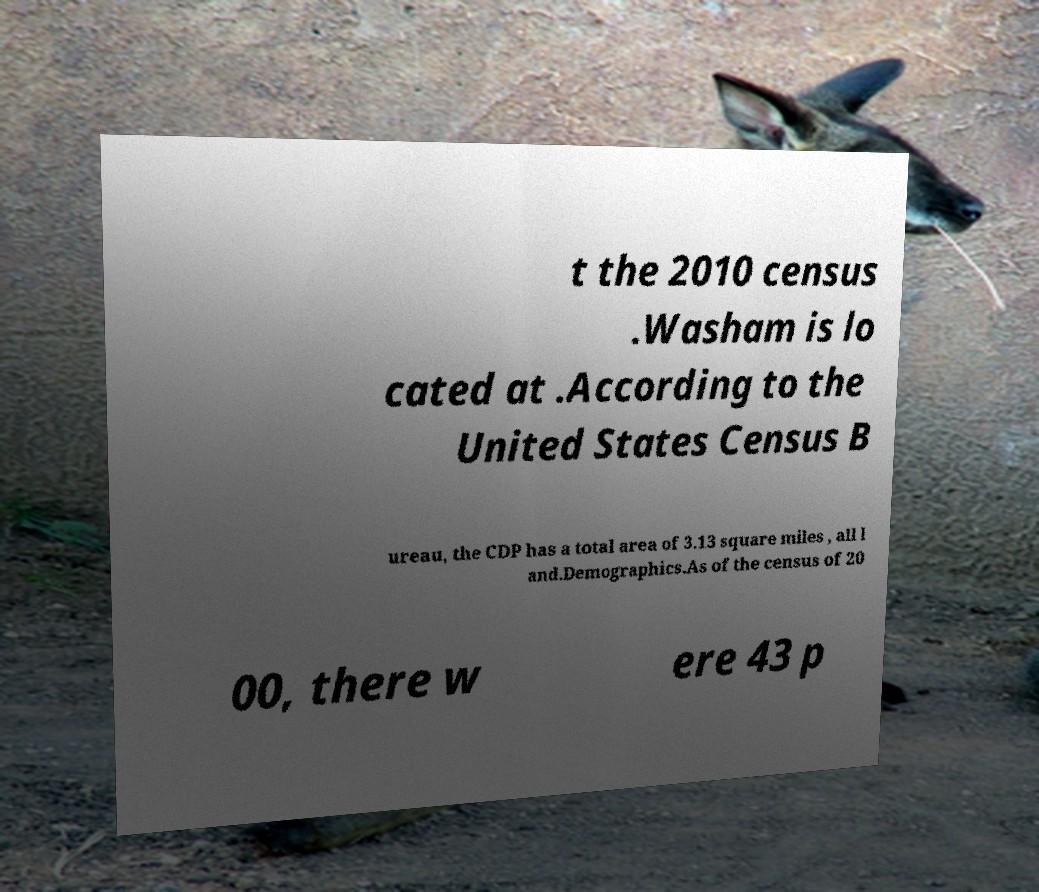There's text embedded in this image that I need extracted. Can you transcribe it verbatim? t the 2010 census .Washam is lo cated at .According to the United States Census B ureau, the CDP has a total area of 3.13 square miles , all l and.Demographics.As of the census of 20 00, there w ere 43 p 